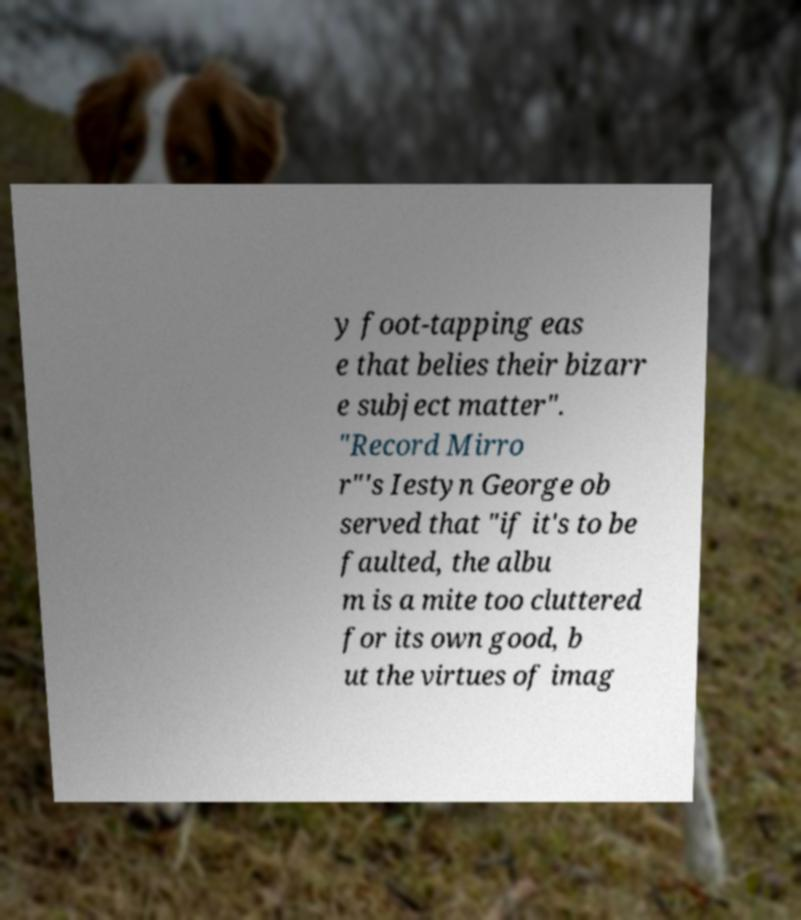Can you read and provide the text displayed in the image?This photo seems to have some interesting text. Can you extract and type it out for me? y foot-tapping eas e that belies their bizarr e subject matter". "Record Mirro r"'s Iestyn George ob served that "if it's to be faulted, the albu m is a mite too cluttered for its own good, b ut the virtues of imag 